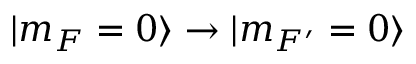Convert formula to latex. <formula><loc_0><loc_0><loc_500><loc_500>| m _ { F } = 0 \rangle \rightarrow | m _ { F ^ { \prime } } = 0 \rangle</formula> 